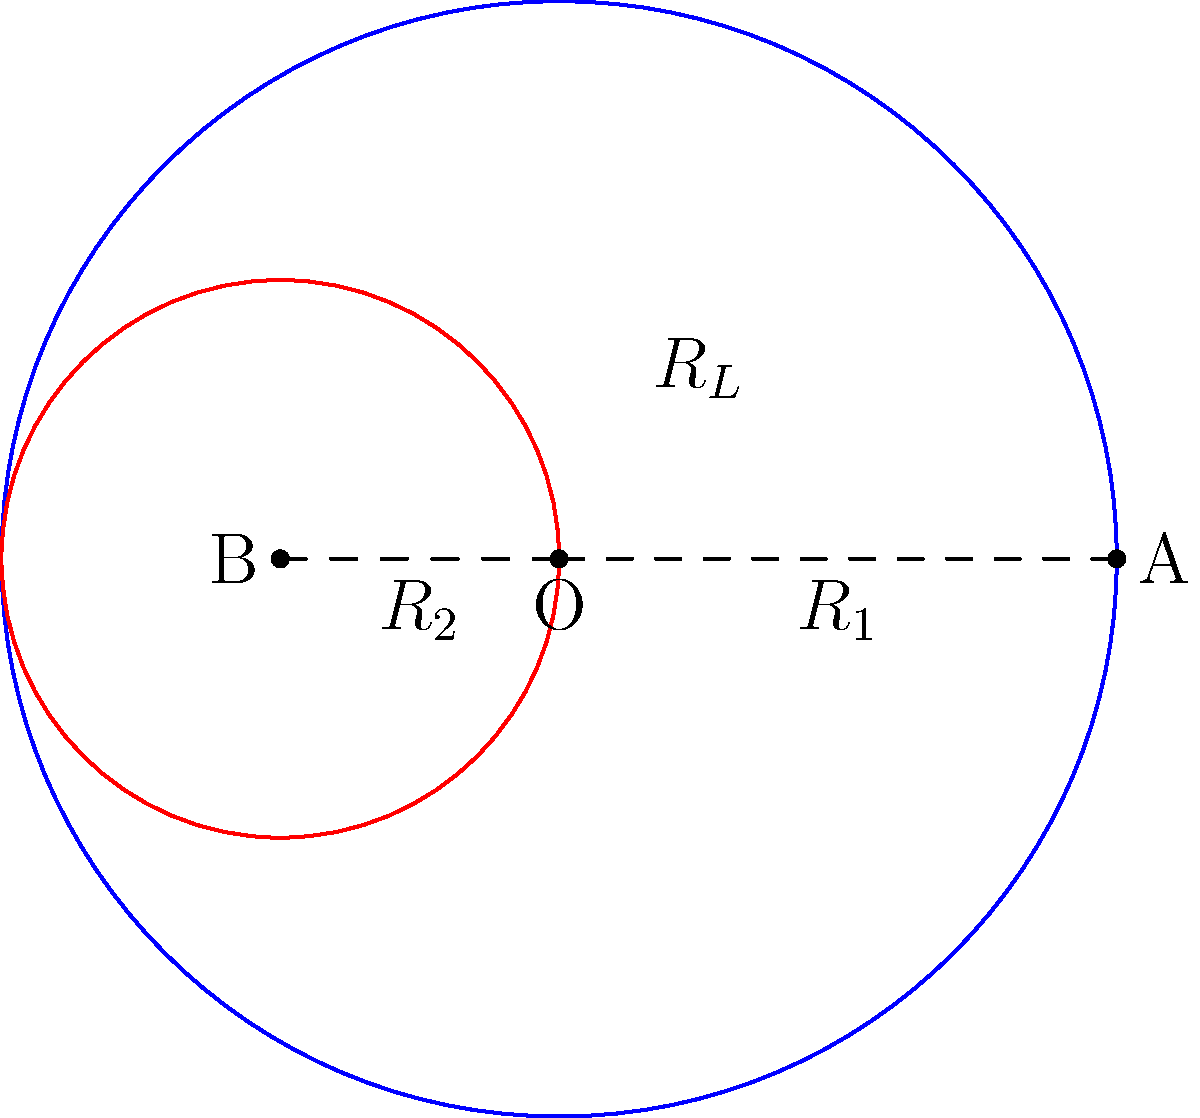In a binary star system, star A has a mass of 4 solar masses, and star B has a mass of 1 solar mass. The distance between their centers is 6 astronomical units (AU). Calculate the Roche lobe radius $R_L$ for star B using the approximation formula:

$$ R_L \approx \frac{0.49q^{2/3}}{0.6q^{2/3} + \ln(1+q^{1/3})} a $$

where $q$ is the mass ratio $M_B/M_A$, and $a$ is the orbital separation. Round your answer to two decimal places. Let's approach this step-by-step:

1) First, we need to calculate the mass ratio $q$:
   $q = M_B / M_A = 1 / 4 = 0.25$

2) We're given that the orbital separation $a = 6$ AU.

3) Now, let's substitute these values into the Roche lobe formula:

   $R_L \approx \frac{0.49q^{2/3}}{0.6q^{2/3} + \ln(1+q^{1/3})} a$

4) Calculate $q^{2/3}$ and $q^{1/3}$:
   $q^{2/3} = 0.25^{2/3} \approx 0.3968$
   $q^{1/3} = 0.25^{1/3} \approx 0.6300$

5) Substitute these into the formula:
   $R_L \approx \frac{0.49(0.3968)}{0.6(0.3968) + \ln(1+0.6300)} 6$

6) Evaluate the numerator and denominator:
   $R_L \approx \frac{0.1944}{0.2381 + 0.4886} 6$
   $R_L \approx \frac{0.1944}{0.7267} 6$

7) Divide and multiply:
   $R_L \approx 0.2675 * 6 = 1.6050$

8) Rounding to two decimal places:
   $R_L \approx 1.61$ AU
Answer: 1.61 AU 